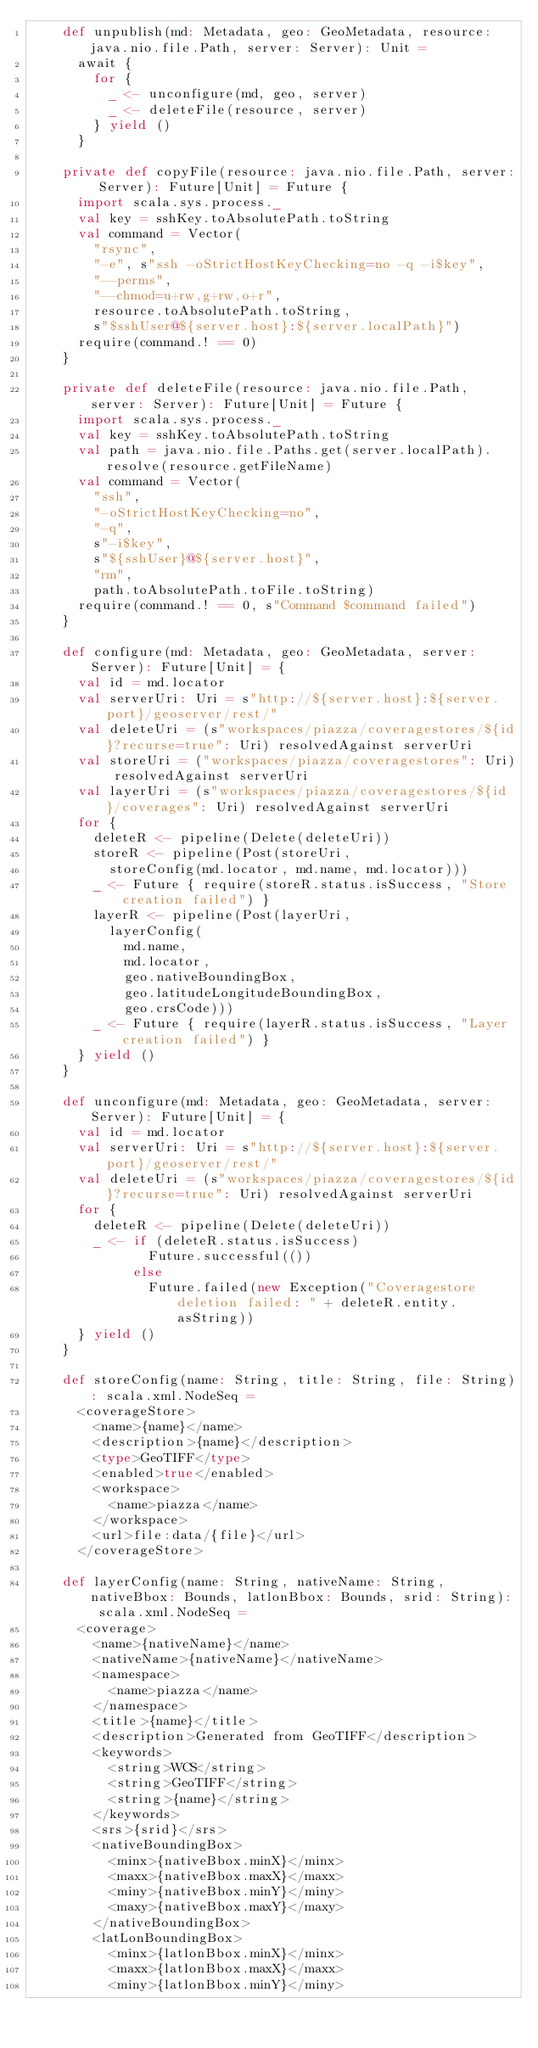<code> <loc_0><loc_0><loc_500><loc_500><_Scala_>    def unpublish(md: Metadata, geo: GeoMetadata, resource: java.nio.file.Path, server: Server): Unit =
      await {
        for {
          _ <- unconfigure(md, geo, server)
          _ <- deleteFile(resource, server)
        } yield ()
      }

    private def copyFile(resource: java.nio.file.Path, server: Server): Future[Unit] = Future {
      import scala.sys.process._
      val key = sshKey.toAbsolutePath.toString
      val command = Vector(
        "rsync",
        "-e", s"ssh -oStrictHostKeyChecking=no -q -i$key",
        "--perms",
        "--chmod=u+rw,g+rw,o+r",
        resource.toAbsolutePath.toString,
        s"$sshUser@${server.host}:${server.localPath}")
      require(command.! == 0)
    }

    private def deleteFile(resource: java.nio.file.Path, server: Server): Future[Unit] = Future {
      import scala.sys.process._
      val key = sshKey.toAbsolutePath.toString
      val path = java.nio.file.Paths.get(server.localPath).resolve(resource.getFileName)
      val command = Vector(
        "ssh",
        "-oStrictHostKeyChecking=no",
        "-q",
        s"-i$key",
        s"${sshUser}@${server.host}",
        "rm",
        path.toAbsolutePath.toFile.toString)
      require(command.! == 0, s"Command $command failed")
    }

    def configure(md: Metadata, geo: GeoMetadata, server: Server): Future[Unit] = {
      val id = md.locator
      val serverUri: Uri = s"http://${server.host}:${server.port}/geoserver/rest/"
      val deleteUri = (s"workspaces/piazza/coveragestores/${id}?recurse=true": Uri) resolvedAgainst serverUri
      val storeUri = ("workspaces/piazza/coveragestores": Uri) resolvedAgainst serverUri
      val layerUri = (s"workspaces/piazza/coveragestores/${id}/coverages": Uri) resolvedAgainst serverUri
      for {
        deleteR <- pipeline(Delete(deleteUri))
        storeR <- pipeline(Post(storeUri,
          storeConfig(md.locator, md.name, md.locator)))
        _ <- Future { require(storeR.status.isSuccess, "Store creation failed") }
        layerR <- pipeline(Post(layerUri,
          layerConfig(
            md.name,
            md.locator,
            geo.nativeBoundingBox,
            geo.latitudeLongitudeBoundingBox,
            geo.crsCode)))
        _ <- Future { require(layerR.status.isSuccess, "Layer creation failed") }
      } yield ()
    }

    def unconfigure(md: Metadata, geo: GeoMetadata, server: Server): Future[Unit] = {
      val id = md.locator
      val serverUri: Uri = s"http://${server.host}:${server.port}/geoserver/rest/"
      val deleteUri = (s"workspaces/piazza/coveragestores/${id}?recurse=true": Uri) resolvedAgainst serverUri
      for {
        deleteR <- pipeline(Delete(deleteUri))
        _ <- if (deleteR.status.isSuccess)
               Future.successful(())
             else
               Future.failed(new Exception("Coveragestore deletion failed: " + deleteR.entity.asString))
      } yield ()
    }

    def storeConfig(name: String, title: String, file: String): scala.xml.NodeSeq =
      <coverageStore>
        <name>{name}</name>
        <description>{name}</description>
        <type>GeoTIFF</type>
        <enabled>true</enabled>
        <workspace>
          <name>piazza</name>
        </workspace>
        <url>file:data/{file}</url>
      </coverageStore>

    def layerConfig(name: String, nativeName: String, nativeBbox: Bounds, latlonBbox: Bounds, srid: String): scala.xml.NodeSeq =
      <coverage>
        <name>{nativeName}</name>
        <nativeName>{nativeName}</nativeName>
        <namespace>
          <name>piazza</name>
        </namespace>
        <title>{name}</title>
        <description>Generated from GeoTIFF</description>
        <keywords>
          <string>WCS</string>
          <string>GeoTIFF</string>
          <string>{name}</string>
        </keywords>
        <srs>{srid}</srs>
        <nativeBoundingBox>
          <minx>{nativeBbox.minX}</minx>
          <maxx>{nativeBbox.maxX}</maxx>
          <miny>{nativeBbox.minY}</miny>
          <maxy>{nativeBbox.maxY}</maxy>
        </nativeBoundingBox>
        <latLonBoundingBox>
          <minx>{latlonBbox.minX}</minx>
          <maxx>{latlonBbox.maxX}</maxx>
          <miny>{latlonBbox.minY}</miny></code> 